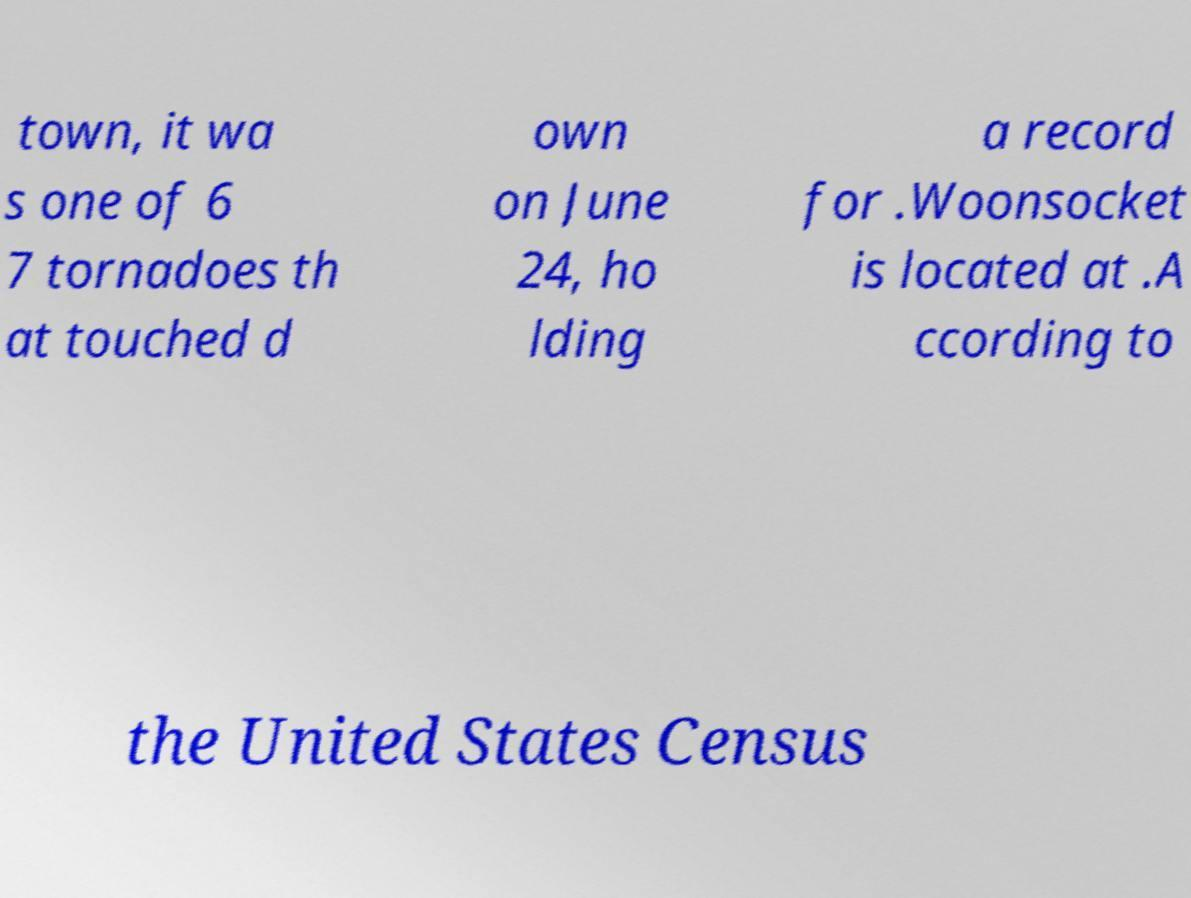There's text embedded in this image that I need extracted. Can you transcribe it verbatim? town, it wa s one of 6 7 tornadoes th at touched d own on June 24, ho lding a record for .Woonsocket is located at .A ccording to the United States Census 